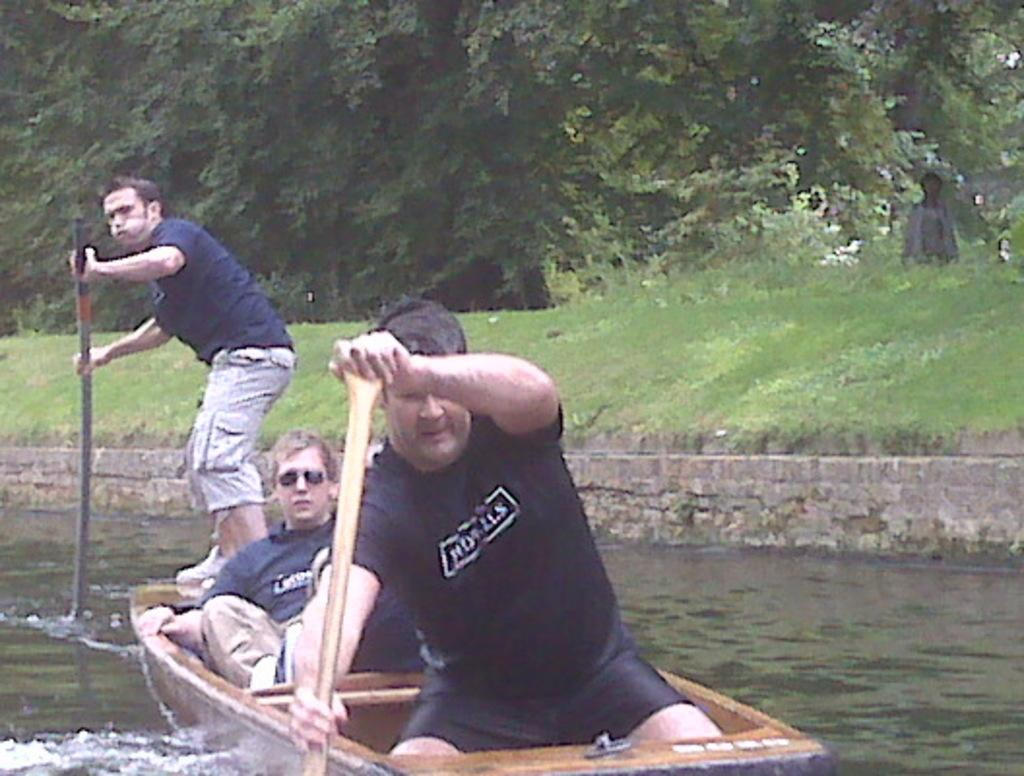What activity are the people in the foreground of the picture engaged in? The people are rowing a boat in the foreground of the picture. Where is the boat located? The boat is in a water body. What can be seen in the center of the picture? There are trees, plants, and grass in the center of the picture. How many waves can be seen crashing against the boat in the image? There are no waves present in the image; the boat is in a calm water body. What type of lock is used to secure the boat in the image? There is no lock visible in the image, as the boat is being rowed by people. 